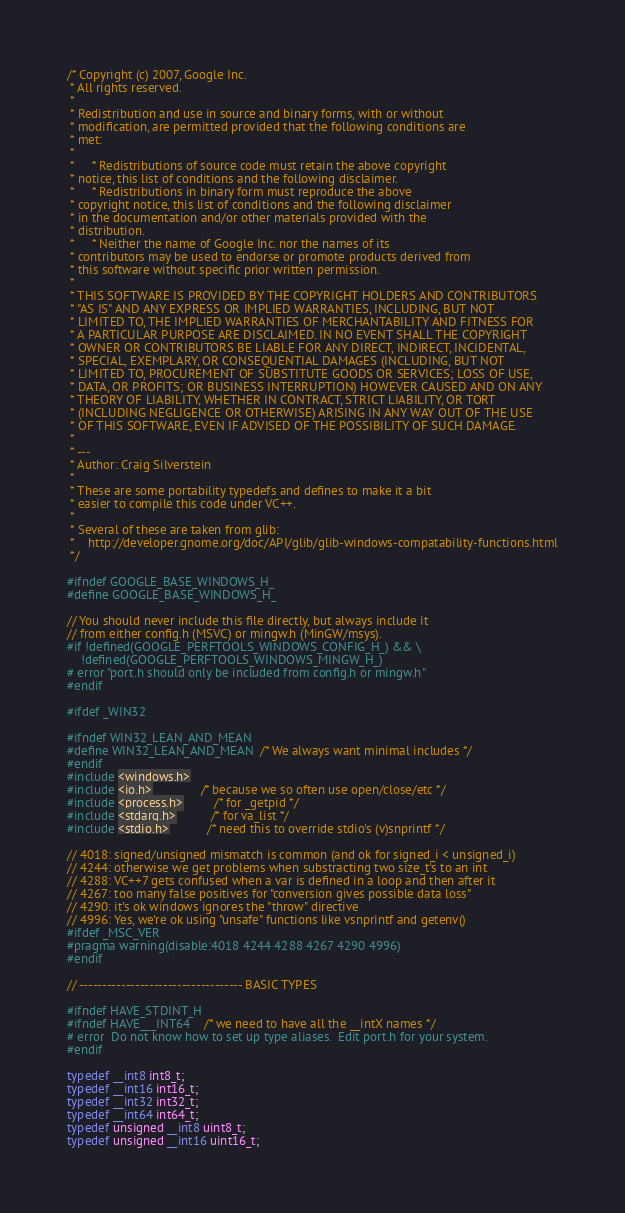Convert code to text. <code><loc_0><loc_0><loc_500><loc_500><_C_>/* Copyright (c) 2007, Google Inc.
 * All rights reserved.
 *
 * Redistribution and use in source and binary forms, with or without
 * modification, are permitted provided that the following conditions are
 * met:
 *
 *     * Redistributions of source code must retain the above copyright
 * notice, this list of conditions and the following disclaimer.
 *     * Redistributions in binary form must reproduce the above
 * copyright notice, this list of conditions and the following disclaimer
 * in the documentation and/or other materials provided with the
 * distribution.
 *     * Neither the name of Google Inc. nor the names of its
 * contributors may be used to endorse or promote products derived from
 * this software without specific prior written permission.
 *
 * THIS SOFTWARE IS PROVIDED BY THE COPYRIGHT HOLDERS AND CONTRIBUTORS
 * "AS IS" AND ANY EXPRESS OR IMPLIED WARRANTIES, INCLUDING, BUT NOT
 * LIMITED TO, THE IMPLIED WARRANTIES OF MERCHANTABILITY AND FITNESS FOR
 * A PARTICULAR PURPOSE ARE DISCLAIMED. IN NO EVENT SHALL THE COPYRIGHT
 * OWNER OR CONTRIBUTORS BE LIABLE FOR ANY DIRECT, INDIRECT, INCIDENTAL,
 * SPECIAL, EXEMPLARY, OR CONSEQUENTIAL DAMAGES (INCLUDING, BUT NOT
 * LIMITED TO, PROCUREMENT OF SUBSTITUTE GOODS OR SERVICES; LOSS OF USE,
 * DATA, OR PROFITS; OR BUSINESS INTERRUPTION) HOWEVER CAUSED AND ON ANY
 * THEORY OF LIABILITY, WHETHER IN CONTRACT, STRICT LIABILITY, OR TORT
 * (INCLUDING NEGLIGENCE OR OTHERWISE) ARISING IN ANY WAY OUT OF THE USE
 * OF THIS SOFTWARE, EVEN IF ADVISED OF THE POSSIBILITY OF SUCH DAMAGE.
 *
 * ---
 * Author: Craig Silverstein
 *
 * These are some portability typedefs and defines to make it a bit
 * easier to compile this code under VC++.
 *
 * Several of these are taken from glib:
 *    http://developer.gnome.org/doc/API/glib/glib-windows-compatability-functions.html
 */

#ifndef GOOGLE_BASE_WINDOWS_H_
#define GOOGLE_BASE_WINDOWS_H_

// You should never include this file directly, but always include it
// from either config.h (MSVC) or mingw.h (MinGW/msys).
#if !defined(GOOGLE_PERFTOOLS_WINDOWS_CONFIG_H_) && \
    !defined(GOOGLE_PERFTOOLS_WINDOWS_MINGW_H_)
# error "port.h should only be included from config.h or mingw.h"
#endif

#ifdef _WIN32

#ifndef WIN32_LEAN_AND_MEAN
#define WIN32_LEAN_AND_MEAN  /* We always want minimal includes */
#endif
#include <windows.h>
#include <io.h>              /* because we so often use open/close/etc */
#include <process.h>         /* for _getpid */
#include <stdarg.h>          /* for va_list */
#include <stdio.h>           /* need this to override stdio's (v)snprintf */

// 4018: signed/unsigned mismatch is common (and ok for signed_i < unsigned_i)
// 4244: otherwise we get problems when substracting two size_t's to an int
// 4288: VC++7 gets confused when a var is defined in a loop and then after it
// 4267: too many false positives for "conversion gives possible data loss"
// 4290: it's ok windows ignores the "throw" directive
// 4996: Yes, we're ok using "unsafe" functions like vsnprintf and getenv()
#ifdef _MSC_VER
#pragma warning(disable:4018 4244 4288 4267 4290 4996)
#endif

// ----------------------------------- BASIC TYPES

#ifndef HAVE_STDINT_H
#ifndef HAVE___INT64    /* we need to have all the __intX names */
# error  Do not know how to set up type aliases.  Edit port.h for your system.
#endif

typedef __int8 int8_t;
typedef __int16 int16_t;
typedef __int32 int32_t;
typedef __int64 int64_t;
typedef unsigned __int8 uint8_t;
typedef unsigned __int16 uint16_t;</code> 